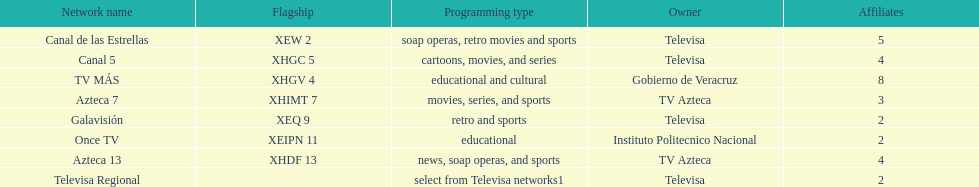What is the sole station that has 8 associated channels? TV MÁS. Parse the full table. {'header': ['Network name', 'Flagship', 'Programming type', 'Owner', 'Affiliates'], 'rows': [['Canal de las Estrellas', 'XEW 2', 'soap operas, retro movies and sports', 'Televisa', '5'], ['Canal 5', 'XHGC 5', 'cartoons, movies, and series', 'Televisa', '4'], ['TV MÁS', 'XHGV 4', 'educational and cultural', 'Gobierno de Veracruz', '8'], ['Azteca 7', 'XHIMT 7', 'movies, series, and sports', 'TV Azteca', '3'], ['Galavisión', 'XEQ 9', 'retro and sports', 'Televisa', '2'], ['Once TV', 'XEIPN 11', 'educational', 'Instituto Politecnico Nacional', '2'], ['Azteca 13', 'XHDF 13', 'news, soap operas, and sports', 'TV Azteca', '4'], ['Televisa Regional', '', 'select from Televisa networks1', 'Televisa', '2']]} 